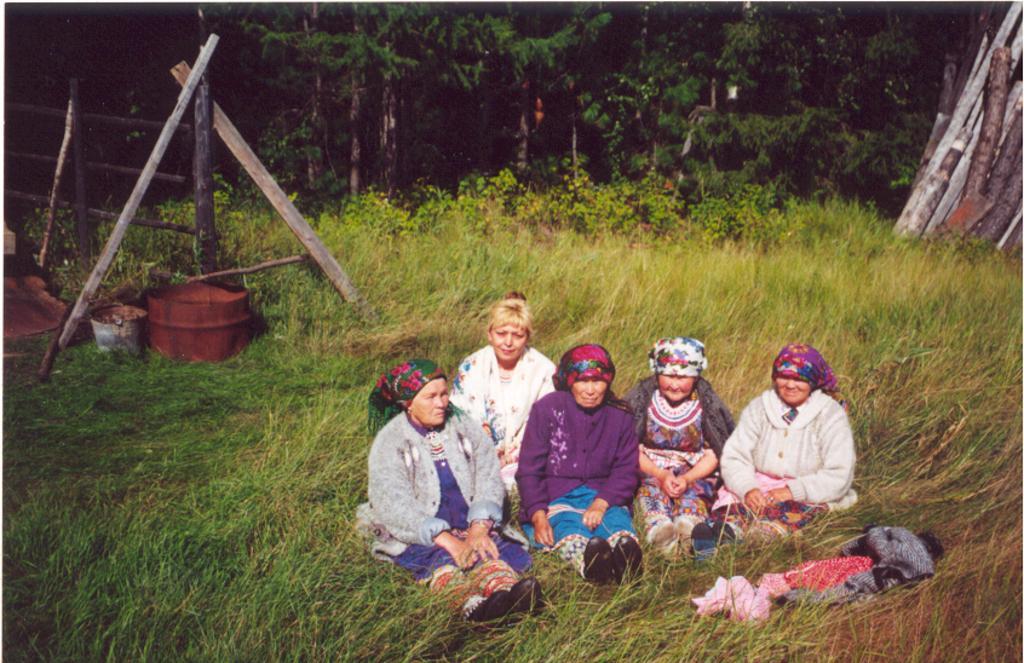In one or two sentences, can you explain what this image depicts? A group of people are sitting in the grass. They wore headgear behind them there are trees in this image. 